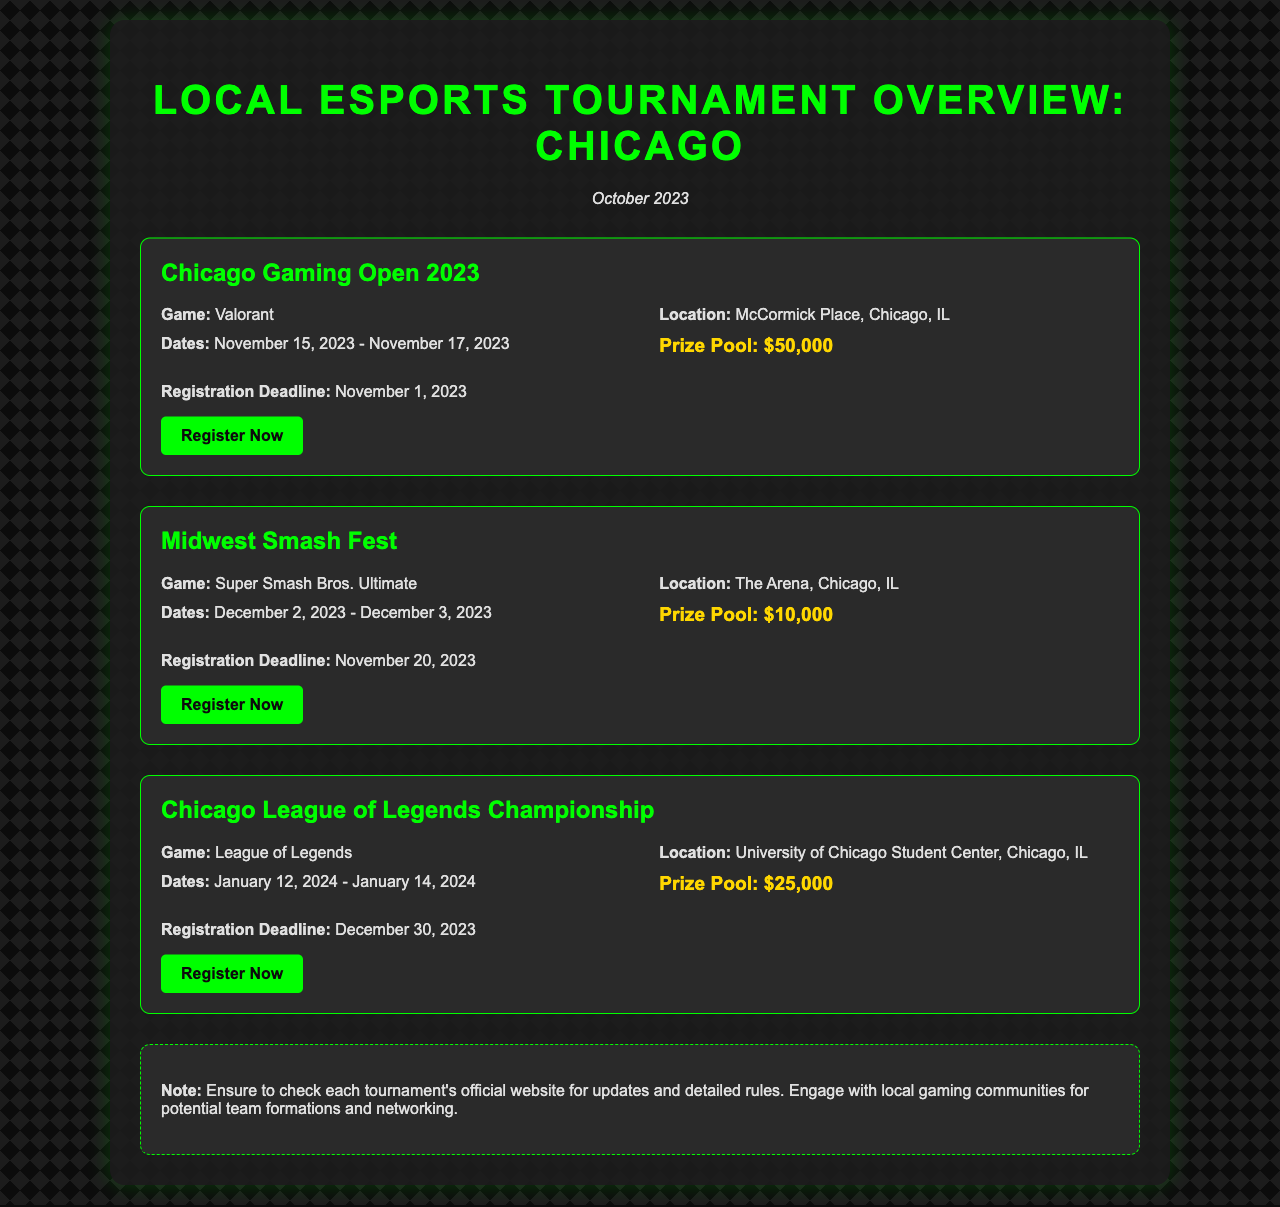what is the highest prize pool in the document? The highest prize pool among the tournaments listed is $50,000 from the Chicago Gaming Open 2023.
Answer: $50,000 when does the Chicago Gaming Open 2023 start? The Chicago Gaming Open 2023 starts on November 15, 2023.
Answer: November 15, 2023 what game is featured in the Midwest Smash Fest? The game featured in the Midwest Smash Fest is Super Smash Bros. Ultimate.
Answer: Super Smash Bros. Ultimate what is the registration deadline for the League of Legends Championship? The registration deadline for the League of Legends Championship is December 30, 2023.
Answer: December 30, 2023 where is the location of the Chicago League of Legends Championship? The location of the Chicago League of Legends Championship is University of Chicago Student Center, Chicago, IL.
Answer: University of Chicago Student Center, Chicago, IL how many days does the Midwest Smash Fest last? The Midwest Smash Fest lasts for two days, from December 2 to December 3, 2023.
Answer: Two days what is the prize pool of the Chicago Gaming Open 2023? The prize pool of the Chicago Gaming Open 2023 is $50,000.
Answer: $50,000 which tournament has a later registration deadline, Chicago Gaming Open 2023 or Midwest Smash Fest? The registration deadline for the Midwest Smash Fest is later, on November 20, 2023, compared to the Chicago Gaming Open's November 1 deadline.
Answer: Midwest Smash Fest how many tournaments are mentioned in the document? There are three tournaments mentioned in the document.
Answer: Three tournaments 